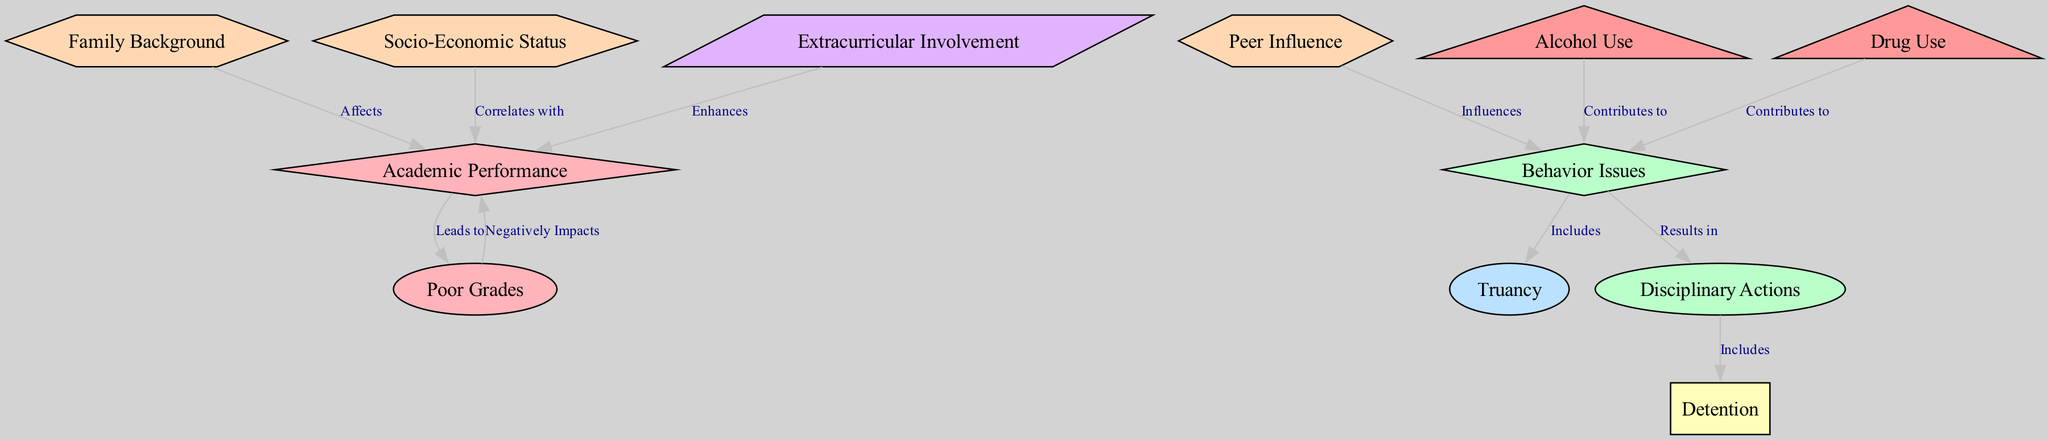What are the two main nodes in the diagram? The diagram features two main nodes: "Academic Performance" and "Behavior Issues". These nodes are central to the overall theme of the relationships illustrated.
Answer: Academic Performance, Behavior Issues How many edges connect to the node "behavior issues"? There are four edges connecting to the node "behavior issues". Each edge represents a different relationship involving behavior issues, indicating its connections to disciplinary actions, truancy, and the influences that affect it, such as alcohol and peers.
Answer: 4 What factor influences behavior issues? The diagram indicates that "Peer Influence" influences behavior issues, emphasizing the social aspects that can affect adolescent behavior.
Answer: Peer Influence What relationship does "poor grades" have with "academic performance"? "Poor Grades" negatively impacts "Academic Performance", showing a direct correlation in the academic success of students. This relationship is crucial as it highlights how academic performance can deteriorate due to insufficient grades.
Answer: Negatively Impacts Which two factors contribute to behavior issues? The diagram shows that both "Alcohol Use" and "Drug Use" contribute to behavior issues, indicating a link between substance use and behavioral problems in adolescents.
Answer: Alcohol Use, Drug Use What does "extracurricular involvement" do for academic performance? "Extracurricular Involvement" enhances academic performance, suggesting that participation in activities outside of academics can positively affect students’ success in school.
Answer: Enhances How does "family background" affect academic performance? "Family Background" affects academic performance, indicating that a student's home environment and circumstances can significantly influence their educational achievements.
Answer: Affects What is the result of "behavior issues"? The result of behavior issues is "Disciplinary Actions", which implies that negative behaviors often lead to formal consequences within educational settings.
Answer: Disciplinary Actions 